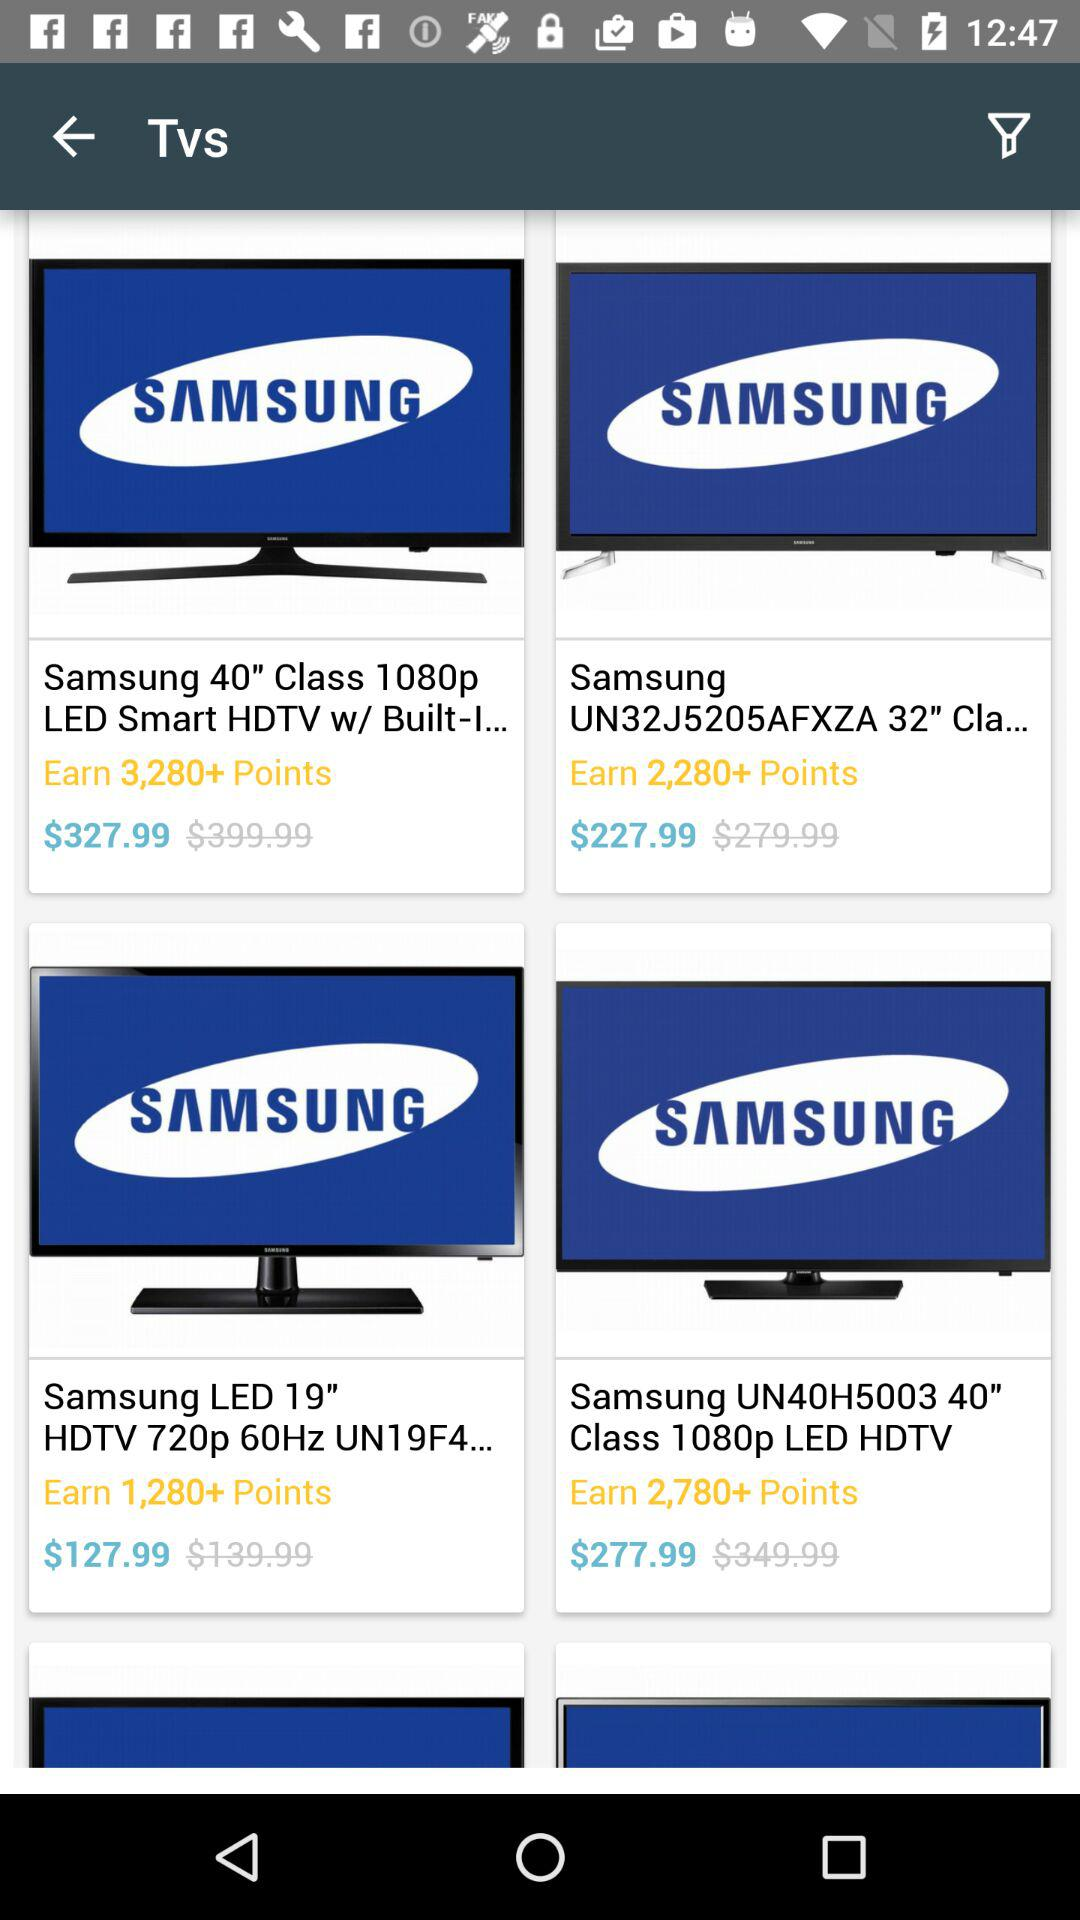How many points can we earn with "Samsung LED 19" HDTV 720p 60Hz"? You can earn 1,280+ points. 